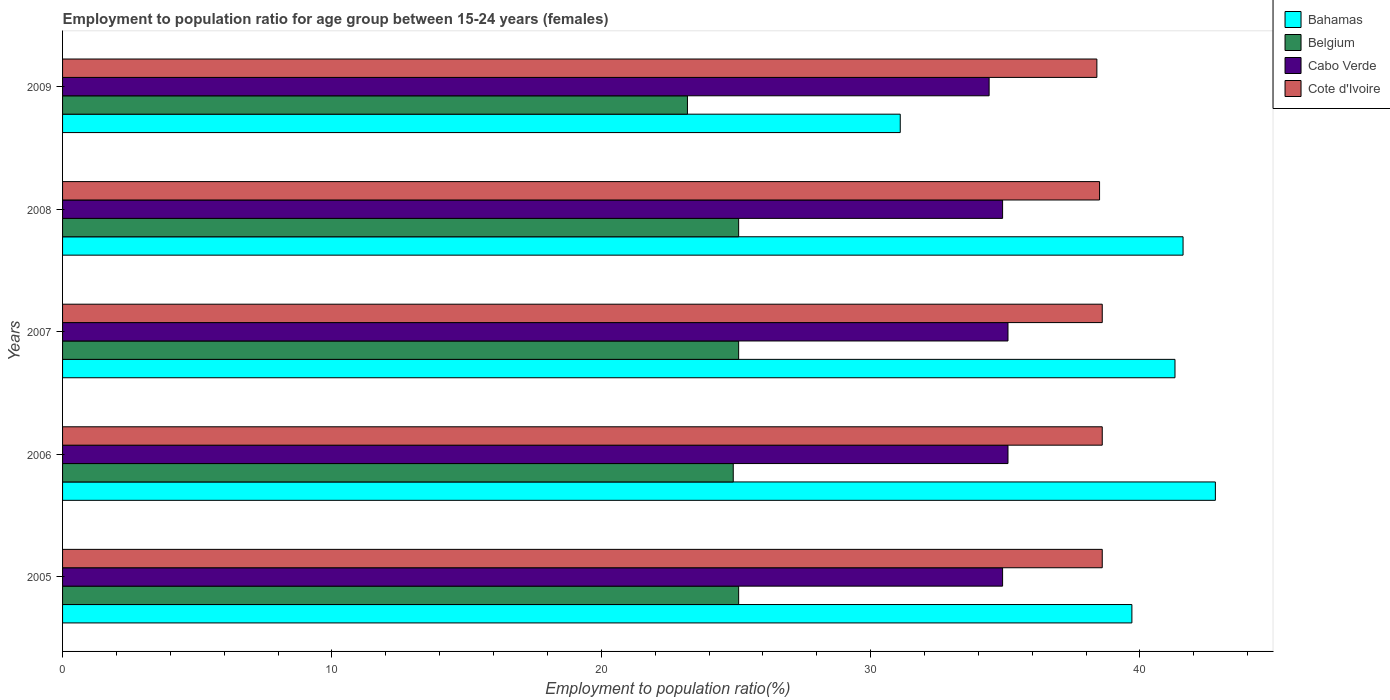How many groups of bars are there?
Keep it short and to the point. 5. Are the number of bars per tick equal to the number of legend labels?
Your answer should be compact. Yes. How many bars are there on the 2nd tick from the bottom?
Ensure brevity in your answer.  4. In how many cases, is the number of bars for a given year not equal to the number of legend labels?
Make the answer very short. 0. What is the employment to population ratio in Bahamas in 2005?
Your answer should be very brief. 39.7. Across all years, what is the maximum employment to population ratio in Cote d'Ivoire?
Keep it short and to the point. 38.6. Across all years, what is the minimum employment to population ratio in Cote d'Ivoire?
Your answer should be compact. 38.4. In which year was the employment to population ratio in Bahamas maximum?
Your answer should be very brief. 2006. What is the total employment to population ratio in Bahamas in the graph?
Keep it short and to the point. 196.5. What is the difference between the employment to population ratio in Bahamas in 2006 and that in 2009?
Provide a succinct answer. 11.7. What is the difference between the employment to population ratio in Bahamas in 2006 and the employment to population ratio in Belgium in 2008?
Ensure brevity in your answer.  17.7. What is the average employment to population ratio in Cote d'Ivoire per year?
Make the answer very short. 38.54. In the year 2007, what is the difference between the employment to population ratio in Bahamas and employment to population ratio in Cabo Verde?
Your answer should be very brief. 6.2. What is the ratio of the employment to population ratio in Belgium in 2006 to that in 2008?
Ensure brevity in your answer.  0.99. Is the employment to population ratio in Belgium in 2005 less than that in 2006?
Give a very brief answer. No. Is the difference between the employment to population ratio in Bahamas in 2007 and 2008 greater than the difference between the employment to population ratio in Cabo Verde in 2007 and 2008?
Keep it short and to the point. No. What is the difference between the highest and the second highest employment to population ratio in Cabo Verde?
Your answer should be very brief. 0. What is the difference between the highest and the lowest employment to population ratio in Cabo Verde?
Provide a succinct answer. 0.7. In how many years, is the employment to population ratio in Bahamas greater than the average employment to population ratio in Bahamas taken over all years?
Your response must be concise. 4. What does the 3rd bar from the bottom in 2009 represents?
Your response must be concise. Cabo Verde. Is it the case that in every year, the sum of the employment to population ratio in Cabo Verde and employment to population ratio in Belgium is greater than the employment to population ratio in Bahamas?
Offer a very short reply. Yes. How many bars are there?
Provide a succinct answer. 20. Are all the bars in the graph horizontal?
Offer a terse response. Yes. How many years are there in the graph?
Provide a succinct answer. 5. What is the difference between two consecutive major ticks on the X-axis?
Give a very brief answer. 10. Are the values on the major ticks of X-axis written in scientific E-notation?
Offer a very short reply. No. Does the graph contain any zero values?
Ensure brevity in your answer.  No. Does the graph contain grids?
Offer a terse response. No. What is the title of the graph?
Your response must be concise. Employment to population ratio for age group between 15-24 years (females). Does "Euro area" appear as one of the legend labels in the graph?
Ensure brevity in your answer.  No. What is the label or title of the X-axis?
Offer a terse response. Employment to population ratio(%). What is the Employment to population ratio(%) of Bahamas in 2005?
Offer a terse response. 39.7. What is the Employment to population ratio(%) in Belgium in 2005?
Keep it short and to the point. 25.1. What is the Employment to population ratio(%) of Cabo Verde in 2005?
Give a very brief answer. 34.9. What is the Employment to population ratio(%) in Cote d'Ivoire in 2005?
Your answer should be compact. 38.6. What is the Employment to population ratio(%) in Bahamas in 2006?
Give a very brief answer. 42.8. What is the Employment to population ratio(%) in Belgium in 2006?
Offer a terse response. 24.9. What is the Employment to population ratio(%) of Cabo Verde in 2006?
Offer a terse response. 35.1. What is the Employment to population ratio(%) of Cote d'Ivoire in 2006?
Ensure brevity in your answer.  38.6. What is the Employment to population ratio(%) in Bahamas in 2007?
Give a very brief answer. 41.3. What is the Employment to population ratio(%) of Belgium in 2007?
Offer a terse response. 25.1. What is the Employment to population ratio(%) in Cabo Verde in 2007?
Ensure brevity in your answer.  35.1. What is the Employment to population ratio(%) in Cote d'Ivoire in 2007?
Provide a succinct answer. 38.6. What is the Employment to population ratio(%) of Bahamas in 2008?
Make the answer very short. 41.6. What is the Employment to population ratio(%) of Belgium in 2008?
Provide a succinct answer. 25.1. What is the Employment to population ratio(%) of Cabo Verde in 2008?
Your response must be concise. 34.9. What is the Employment to population ratio(%) of Cote d'Ivoire in 2008?
Your answer should be very brief. 38.5. What is the Employment to population ratio(%) of Bahamas in 2009?
Give a very brief answer. 31.1. What is the Employment to population ratio(%) in Belgium in 2009?
Provide a succinct answer. 23.2. What is the Employment to population ratio(%) of Cabo Verde in 2009?
Make the answer very short. 34.4. What is the Employment to population ratio(%) of Cote d'Ivoire in 2009?
Offer a very short reply. 38.4. Across all years, what is the maximum Employment to population ratio(%) of Bahamas?
Your response must be concise. 42.8. Across all years, what is the maximum Employment to population ratio(%) of Belgium?
Provide a succinct answer. 25.1. Across all years, what is the maximum Employment to population ratio(%) of Cabo Verde?
Your answer should be very brief. 35.1. Across all years, what is the maximum Employment to population ratio(%) of Cote d'Ivoire?
Ensure brevity in your answer.  38.6. Across all years, what is the minimum Employment to population ratio(%) of Bahamas?
Your answer should be very brief. 31.1. Across all years, what is the minimum Employment to population ratio(%) of Belgium?
Make the answer very short. 23.2. Across all years, what is the minimum Employment to population ratio(%) in Cabo Verde?
Offer a terse response. 34.4. Across all years, what is the minimum Employment to population ratio(%) in Cote d'Ivoire?
Make the answer very short. 38.4. What is the total Employment to population ratio(%) of Bahamas in the graph?
Ensure brevity in your answer.  196.5. What is the total Employment to population ratio(%) of Belgium in the graph?
Give a very brief answer. 123.4. What is the total Employment to population ratio(%) in Cabo Verde in the graph?
Your answer should be very brief. 174.4. What is the total Employment to population ratio(%) of Cote d'Ivoire in the graph?
Make the answer very short. 192.7. What is the difference between the Employment to population ratio(%) of Bahamas in 2005 and that in 2006?
Make the answer very short. -3.1. What is the difference between the Employment to population ratio(%) in Belgium in 2005 and that in 2006?
Offer a terse response. 0.2. What is the difference between the Employment to population ratio(%) in Bahamas in 2005 and that in 2007?
Your response must be concise. -1.6. What is the difference between the Employment to population ratio(%) in Bahamas in 2005 and that in 2008?
Your response must be concise. -1.9. What is the difference between the Employment to population ratio(%) of Belgium in 2005 and that in 2008?
Your response must be concise. 0. What is the difference between the Employment to population ratio(%) in Bahamas in 2005 and that in 2009?
Ensure brevity in your answer.  8.6. What is the difference between the Employment to population ratio(%) in Belgium in 2005 and that in 2009?
Offer a very short reply. 1.9. What is the difference between the Employment to population ratio(%) in Cabo Verde in 2005 and that in 2009?
Provide a succinct answer. 0.5. What is the difference between the Employment to population ratio(%) in Bahamas in 2006 and that in 2007?
Make the answer very short. 1.5. What is the difference between the Employment to population ratio(%) in Belgium in 2006 and that in 2007?
Ensure brevity in your answer.  -0.2. What is the difference between the Employment to population ratio(%) of Cabo Verde in 2006 and that in 2007?
Make the answer very short. 0. What is the difference between the Employment to population ratio(%) of Bahamas in 2006 and that in 2008?
Offer a terse response. 1.2. What is the difference between the Employment to population ratio(%) in Belgium in 2006 and that in 2008?
Your answer should be very brief. -0.2. What is the difference between the Employment to population ratio(%) of Cabo Verde in 2006 and that in 2008?
Provide a succinct answer. 0.2. What is the difference between the Employment to population ratio(%) in Cote d'Ivoire in 2006 and that in 2008?
Your answer should be compact. 0.1. What is the difference between the Employment to population ratio(%) of Belgium in 2006 and that in 2009?
Provide a succinct answer. 1.7. What is the difference between the Employment to population ratio(%) of Cote d'Ivoire in 2006 and that in 2009?
Make the answer very short. 0.2. What is the difference between the Employment to population ratio(%) of Bahamas in 2007 and that in 2008?
Provide a succinct answer. -0.3. What is the difference between the Employment to population ratio(%) of Cote d'Ivoire in 2007 and that in 2008?
Keep it short and to the point. 0.1. What is the difference between the Employment to population ratio(%) in Bahamas in 2007 and that in 2009?
Offer a terse response. 10.2. What is the difference between the Employment to population ratio(%) in Belgium in 2007 and that in 2009?
Your answer should be compact. 1.9. What is the difference between the Employment to population ratio(%) of Cabo Verde in 2007 and that in 2009?
Your answer should be very brief. 0.7. What is the difference between the Employment to population ratio(%) of Cote d'Ivoire in 2007 and that in 2009?
Your response must be concise. 0.2. What is the difference between the Employment to population ratio(%) in Bahamas in 2008 and that in 2009?
Provide a short and direct response. 10.5. What is the difference between the Employment to population ratio(%) in Cabo Verde in 2008 and that in 2009?
Provide a succinct answer. 0.5. What is the difference between the Employment to population ratio(%) of Cote d'Ivoire in 2008 and that in 2009?
Your answer should be very brief. 0.1. What is the difference between the Employment to population ratio(%) of Bahamas in 2005 and the Employment to population ratio(%) of Cote d'Ivoire in 2006?
Your answer should be compact. 1.1. What is the difference between the Employment to population ratio(%) of Bahamas in 2005 and the Employment to population ratio(%) of Belgium in 2007?
Your answer should be compact. 14.6. What is the difference between the Employment to population ratio(%) of Cabo Verde in 2005 and the Employment to population ratio(%) of Cote d'Ivoire in 2007?
Keep it short and to the point. -3.7. What is the difference between the Employment to population ratio(%) of Bahamas in 2005 and the Employment to population ratio(%) of Cote d'Ivoire in 2008?
Offer a terse response. 1.2. What is the difference between the Employment to population ratio(%) in Belgium in 2005 and the Employment to population ratio(%) in Cabo Verde in 2008?
Your response must be concise. -9.8. What is the difference between the Employment to population ratio(%) of Belgium in 2005 and the Employment to population ratio(%) of Cabo Verde in 2009?
Make the answer very short. -9.3. What is the difference between the Employment to population ratio(%) of Bahamas in 2006 and the Employment to population ratio(%) of Belgium in 2007?
Provide a short and direct response. 17.7. What is the difference between the Employment to population ratio(%) in Belgium in 2006 and the Employment to population ratio(%) in Cabo Verde in 2007?
Make the answer very short. -10.2. What is the difference between the Employment to population ratio(%) of Belgium in 2006 and the Employment to population ratio(%) of Cote d'Ivoire in 2007?
Your answer should be very brief. -13.7. What is the difference between the Employment to population ratio(%) in Cabo Verde in 2006 and the Employment to population ratio(%) in Cote d'Ivoire in 2007?
Your response must be concise. -3.5. What is the difference between the Employment to population ratio(%) in Belgium in 2006 and the Employment to population ratio(%) in Cabo Verde in 2008?
Provide a short and direct response. -10. What is the difference between the Employment to population ratio(%) of Belgium in 2006 and the Employment to population ratio(%) of Cote d'Ivoire in 2008?
Provide a succinct answer. -13.6. What is the difference between the Employment to population ratio(%) in Bahamas in 2006 and the Employment to population ratio(%) in Belgium in 2009?
Your answer should be compact. 19.6. What is the difference between the Employment to population ratio(%) of Bahamas in 2006 and the Employment to population ratio(%) of Cote d'Ivoire in 2009?
Offer a very short reply. 4.4. What is the difference between the Employment to population ratio(%) in Belgium in 2006 and the Employment to population ratio(%) in Cote d'Ivoire in 2009?
Provide a short and direct response. -13.5. What is the difference between the Employment to population ratio(%) in Cabo Verde in 2006 and the Employment to population ratio(%) in Cote d'Ivoire in 2009?
Give a very brief answer. -3.3. What is the difference between the Employment to population ratio(%) of Bahamas in 2007 and the Employment to population ratio(%) of Cabo Verde in 2008?
Give a very brief answer. 6.4. What is the difference between the Employment to population ratio(%) in Bahamas in 2007 and the Employment to population ratio(%) in Belgium in 2009?
Your response must be concise. 18.1. What is the difference between the Employment to population ratio(%) in Bahamas in 2007 and the Employment to population ratio(%) in Cabo Verde in 2009?
Provide a succinct answer. 6.9. What is the difference between the Employment to population ratio(%) of Bahamas in 2007 and the Employment to population ratio(%) of Cote d'Ivoire in 2009?
Make the answer very short. 2.9. What is the difference between the Employment to population ratio(%) in Belgium in 2007 and the Employment to population ratio(%) in Cabo Verde in 2009?
Give a very brief answer. -9.3. What is the difference between the Employment to population ratio(%) in Belgium in 2007 and the Employment to population ratio(%) in Cote d'Ivoire in 2009?
Provide a short and direct response. -13.3. What is the difference between the Employment to population ratio(%) in Cabo Verde in 2007 and the Employment to population ratio(%) in Cote d'Ivoire in 2009?
Ensure brevity in your answer.  -3.3. What is the difference between the Employment to population ratio(%) in Bahamas in 2008 and the Employment to population ratio(%) in Cabo Verde in 2009?
Ensure brevity in your answer.  7.2. What is the difference between the Employment to population ratio(%) in Bahamas in 2008 and the Employment to population ratio(%) in Cote d'Ivoire in 2009?
Your answer should be very brief. 3.2. What is the average Employment to population ratio(%) in Bahamas per year?
Provide a short and direct response. 39.3. What is the average Employment to population ratio(%) of Belgium per year?
Offer a terse response. 24.68. What is the average Employment to population ratio(%) of Cabo Verde per year?
Provide a short and direct response. 34.88. What is the average Employment to population ratio(%) in Cote d'Ivoire per year?
Provide a succinct answer. 38.54. In the year 2005, what is the difference between the Employment to population ratio(%) of Bahamas and Employment to population ratio(%) of Cabo Verde?
Keep it short and to the point. 4.8. In the year 2005, what is the difference between the Employment to population ratio(%) in Belgium and Employment to population ratio(%) in Cote d'Ivoire?
Ensure brevity in your answer.  -13.5. In the year 2005, what is the difference between the Employment to population ratio(%) of Cabo Verde and Employment to population ratio(%) of Cote d'Ivoire?
Offer a terse response. -3.7. In the year 2006, what is the difference between the Employment to population ratio(%) of Bahamas and Employment to population ratio(%) of Belgium?
Give a very brief answer. 17.9. In the year 2006, what is the difference between the Employment to population ratio(%) of Belgium and Employment to population ratio(%) of Cote d'Ivoire?
Make the answer very short. -13.7. In the year 2006, what is the difference between the Employment to population ratio(%) in Cabo Verde and Employment to population ratio(%) in Cote d'Ivoire?
Your answer should be compact. -3.5. In the year 2007, what is the difference between the Employment to population ratio(%) in Bahamas and Employment to population ratio(%) in Belgium?
Offer a terse response. 16.2. In the year 2007, what is the difference between the Employment to population ratio(%) of Cabo Verde and Employment to population ratio(%) of Cote d'Ivoire?
Offer a terse response. -3.5. In the year 2008, what is the difference between the Employment to population ratio(%) of Bahamas and Employment to population ratio(%) of Cote d'Ivoire?
Your answer should be compact. 3.1. In the year 2008, what is the difference between the Employment to population ratio(%) in Belgium and Employment to population ratio(%) in Cabo Verde?
Offer a very short reply. -9.8. In the year 2008, what is the difference between the Employment to population ratio(%) of Belgium and Employment to population ratio(%) of Cote d'Ivoire?
Keep it short and to the point. -13.4. In the year 2008, what is the difference between the Employment to population ratio(%) in Cabo Verde and Employment to population ratio(%) in Cote d'Ivoire?
Offer a very short reply. -3.6. In the year 2009, what is the difference between the Employment to population ratio(%) in Bahamas and Employment to population ratio(%) in Cote d'Ivoire?
Your response must be concise. -7.3. In the year 2009, what is the difference between the Employment to population ratio(%) in Belgium and Employment to population ratio(%) in Cote d'Ivoire?
Give a very brief answer. -15.2. What is the ratio of the Employment to population ratio(%) in Bahamas in 2005 to that in 2006?
Your answer should be very brief. 0.93. What is the ratio of the Employment to population ratio(%) in Cabo Verde in 2005 to that in 2006?
Your answer should be compact. 0.99. What is the ratio of the Employment to population ratio(%) of Bahamas in 2005 to that in 2007?
Your response must be concise. 0.96. What is the ratio of the Employment to population ratio(%) in Cote d'Ivoire in 2005 to that in 2007?
Provide a short and direct response. 1. What is the ratio of the Employment to population ratio(%) of Bahamas in 2005 to that in 2008?
Your response must be concise. 0.95. What is the ratio of the Employment to population ratio(%) of Cote d'Ivoire in 2005 to that in 2008?
Make the answer very short. 1. What is the ratio of the Employment to population ratio(%) of Bahamas in 2005 to that in 2009?
Your response must be concise. 1.28. What is the ratio of the Employment to population ratio(%) in Belgium in 2005 to that in 2009?
Make the answer very short. 1.08. What is the ratio of the Employment to population ratio(%) in Cabo Verde in 2005 to that in 2009?
Your response must be concise. 1.01. What is the ratio of the Employment to population ratio(%) of Cote d'Ivoire in 2005 to that in 2009?
Offer a terse response. 1.01. What is the ratio of the Employment to population ratio(%) of Bahamas in 2006 to that in 2007?
Your response must be concise. 1.04. What is the ratio of the Employment to population ratio(%) of Belgium in 2006 to that in 2007?
Make the answer very short. 0.99. What is the ratio of the Employment to population ratio(%) in Cabo Verde in 2006 to that in 2007?
Your answer should be very brief. 1. What is the ratio of the Employment to population ratio(%) of Cote d'Ivoire in 2006 to that in 2007?
Offer a very short reply. 1. What is the ratio of the Employment to population ratio(%) in Bahamas in 2006 to that in 2008?
Your response must be concise. 1.03. What is the ratio of the Employment to population ratio(%) of Bahamas in 2006 to that in 2009?
Your answer should be compact. 1.38. What is the ratio of the Employment to population ratio(%) in Belgium in 2006 to that in 2009?
Provide a short and direct response. 1.07. What is the ratio of the Employment to population ratio(%) in Cabo Verde in 2006 to that in 2009?
Ensure brevity in your answer.  1.02. What is the ratio of the Employment to population ratio(%) of Bahamas in 2007 to that in 2008?
Your response must be concise. 0.99. What is the ratio of the Employment to population ratio(%) of Cote d'Ivoire in 2007 to that in 2008?
Your answer should be compact. 1. What is the ratio of the Employment to population ratio(%) of Bahamas in 2007 to that in 2009?
Your response must be concise. 1.33. What is the ratio of the Employment to population ratio(%) in Belgium in 2007 to that in 2009?
Offer a very short reply. 1.08. What is the ratio of the Employment to population ratio(%) of Cabo Verde in 2007 to that in 2009?
Give a very brief answer. 1.02. What is the ratio of the Employment to population ratio(%) in Cote d'Ivoire in 2007 to that in 2009?
Provide a succinct answer. 1.01. What is the ratio of the Employment to population ratio(%) of Bahamas in 2008 to that in 2009?
Your answer should be very brief. 1.34. What is the ratio of the Employment to population ratio(%) in Belgium in 2008 to that in 2009?
Keep it short and to the point. 1.08. What is the ratio of the Employment to population ratio(%) of Cabo Verde in 2008 to that in 2009?
Offer a terse response. 1.01. What is the ratio of the Employment to population ratio(%) in Cote d'Ivoire in 2008 to that in 2009?
Ensure brevity in your answer.  1. What is the difference between the highest and the second highest Employment to population ratio(%) of Cabo Verde?
Provide a succinct answer. 0. What is the difference between the highest and the second highest Employment to population ratio(%) of Cote d'Ivoire?
Your answer should be compact. 0. What is the difference between the highest and the lowest Employment to population ratio(%) of Belgium?
Your answer should be very brief. 1.9. What is the difference between the highest and the lowest Employment to population ratio(%) in Cabo Verde?
Your response must be concise. 0.7. 